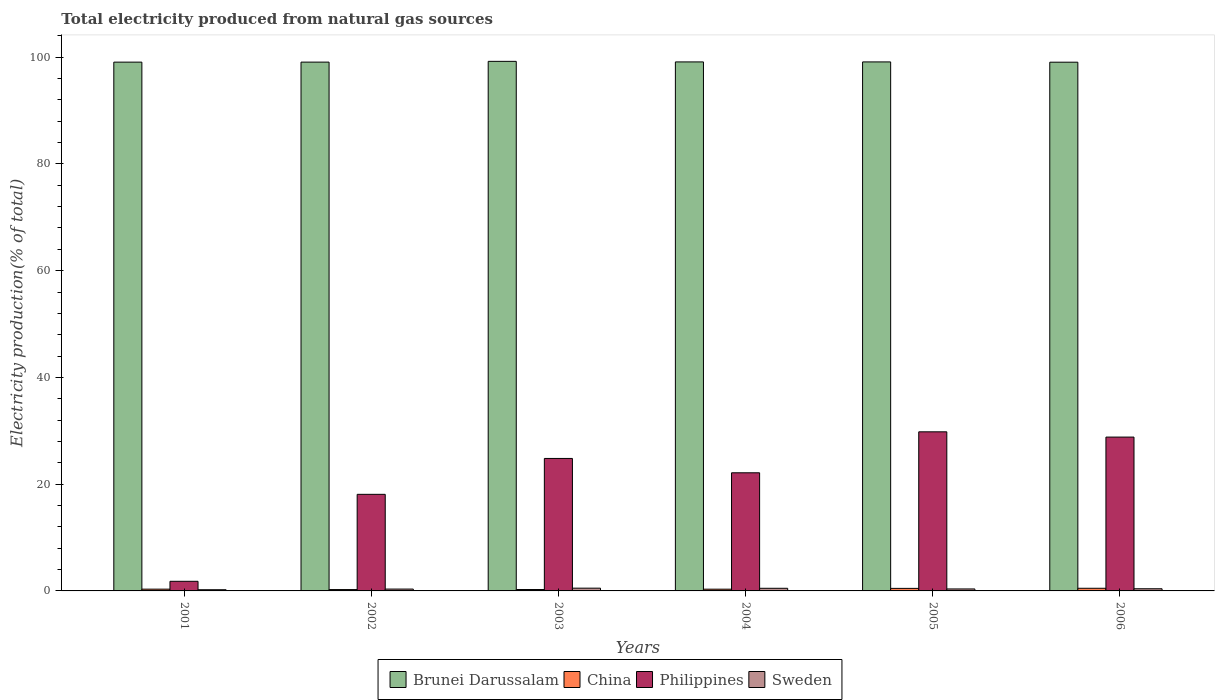How many bars are there on the 2nd tick from the left?
Your answer should be very brief. 4. In how many cases, is the number of bars for a given year not equal to the number of legend labels?
Give a very brief answer. 0. What is the total electricity produced in Philippines in 2006?
Your answer should be very brief. 28.82. Across all years, what is the maximum total electricity produced in Sweden?
Provide a short and direct response. 0.52. Across all years, what is the minimum total electricity produced in China?
Provide a succinct answer. 0.25. In which year was the total electricity produced in Sweden maximum?
Make the answer very short. 2003. What is the total total electricity produced in Philippines in the graph?
Your answer should be compact. 125.48. What is the difference between the total electricity produced in Brunei Darussalam in 2001 and that in 2006?
Offer a terse response. 0.01. What is the difference between the total electricity produced in Brunei Darussalam in 2005 and the total electricity produced in Philippines in 2001?
Keep it short and to the point. 97.31. What is the average total electricity produced in Brunei Darussalam per year?
Provide a short and direct response. 99.11. In the year 2006, what is the difference between the total electricity produced in Philippines and total electricity produced in China?
Your response must be concise. 28.33. What is the ratio of the total electricity produced in Brunei Darussalam in 2005 to that in 2006?
Your answer should be compact. 1. Is the total electricity produced in Brunei Darussalam in 2004 less than that in 2006?
Ensure brevity in your answer.  No. What is the difference between the highest and the second highest total electricity produced in Brunei Darussalam?
Offer a terse response. 0.11. What is the difference between the highest and the lowest total electricity produced in China?
Keep it short and to the point. 0.24. In how many years, is the total electricity produced in Brunei Darussalam greater than the average total electricity produced in Brunei Darussalam taken over all years?
Offer a very short reply. 3. Is the sum of the total electricity produced in Philippines in 2002 and 2006 greater than the maximum total electricity produced in Sweden across all years?
Provide a succinct answer. Yes. Is it the case that in every year, the sum of the total electricity produced in Brunei Darussalam and total electricity produced in Sweden is greater than the sum of total electricity produced in Philippines and total electricity produced in China?
Your answer should be very brief. Yes. What does the 3rd bar from the left in 2002 represents?
Make the answer very short. Philippines. What does the 1st bar from the right in 2006 represents?
Provide a short and direct response. Sweden. How many years are there in the graph?
Keep it short and to the point. 6. What is the difference between two consecutive major ticks on the Y-axis?
Provide a succinct answer. 20. Does the graph contain any zero values?
Keep it short and to the point. No. Does the graph contain grids?
Make the answer very short. No. How are the legend labels stacked?
Keep it short and to the point. Horizontal. What is the title of the graph?
Make the answer very short. Total electricity produced from natural gas sources. What is the label or title of the X-axis?
Offer a terse response. Years. What is the label or title of the Y-axis?
Provide a succinct answer. Electricity production(% of total). What is the Electricity production(% of total) of Brunei Darussalam in 2001?
Offer a terse response. 99.07. What is the Electricity production(% of total) of China in 2001?
Provide a short and direct response. 0.33. What is the Electricity production(% of total) of Philippines in 2001?
Keep it short and to the point. 1.8. What is the Electricity production(% of total) of Sweden in 2001?
Your response must be concise. 0.22. What is the Electricity production(% of total) of Brunei Darussalam in 2002?
Your response must be concise. 99.07. What is the Electricity production(% of total) in China in 2002?
Ensure brevity in your answer.  0.25. What is the Electricity production(% of total) of Philippines in 2002?
Make the answer very short. 18.1. What is the Electricity production(% of total) of Sweden in 2002?
Keep it short and to the point. 0.35. What is the Electricity production(% of total) of Brunei Darussalam in 2003?
Your answer should be compact. 99.22. What is the Electricity production(% of total) of China in 2003?
Keep it short and to the point. 0.26. What is the Electricity production(% of total) of Philippines in 2003?
Make the answer very short. 24.82. What is the Electricity production(% of total) of Sweden in 2003?
Provide a succinct answer. 0.52. What is the Electricity production(% of total) of Brunei Darussalam in 2004?
Keep it short and to the point. 99.11. What is the Electricity production(% of total) of China in 2004?
Your answer should be compact. 0.33. What is the Electricity production(% of total) in Philippines in 2004?
Provide a short and direct response. 22.13. What is the Electricity production(% of total) of Sweden in 2004?
Your answer should be compact. 0.49. What is the Electricity production(% of total) of Brunei Darussalam in 2005?
Provide a succinct answer. 99.11. What is the Electricity production(% of total) of China in 2005?
Provide a short and direct response. 0.48. What is the Electricity production(% of total) in Philippines in 2005?
Offer a terse response. 29.81. What is the Electricity production(% of total) of Sweden in 2005?
Your answer should be compact. 0.37. What is the Electricity production(% of total) in Brunei Darussalam in 2006?
Your response must be concise. 99.06. What is the Electricity production(% of total) in China in 2006?
Your answer should be compact. 0.5. What is the Electricity production(% of total) of Philippines in 2006?
Keep it short and to the point. 28.82. What is the Electricity production(% of total) of Sweden in 2006?
Your answer should be compact. 0.41. Across all years, what is the maximum Electricity production(% of total) in Brunei Darussalam?
Your answer should be very brief. 99.22. Across all years, what is the maximum Electricity production(% of total) in China?
Keep it short and to the point. 0.5. Across all years, what is the maximum Electricity production(% of total) in Philippines?
Provide a succinct answer. 29.81. Across all years, what is the maximum Electricity production(% of total) in Sweden?
Provide a short and direct response. 0.52. Across all years, what is the minimum Electricity production(% of total) of Brunei Darussalam?
Your answer should be compact. 99.06. Across all years, what is the minimum Electricity production(% of total) in China?
Provide a succinct answer. 0.25. Across all years, what is the minimum Electricity production(% of total) of Philippines?
Give a very brief answer. 1.8. Across all years, what is the minimum Electricity production(% of total) of Sweden?
Your answer should be compact. 0.22. What is the total Electricity production(% of total) of Brunei Darussalam in the graph?
Offer a terse response. 594.64. What is the total Electricity production(% of total) of China in the graph?
Make the answer very short. 2.15. What is the total Electricity production(% of total) of Philippines in the graph?
Provide a succinct answer. 125.48. What is the total Electricity production(% of total) of Sweden in the graph?
Offer a very short reply. 2.36. What is the difference between the Electricity production(% of total) of Brunei Darussalam in 2001 and that in 2002?
Offer a very short reply. -0.01. What is the difference between the Electricity production(% of total) in China in 2001 and that in 2002?
Offer a very short reply. 0.08. What is the difference between the Electricity production(% of total) of Philippines in 2001 and that in 2002?
Your answer should be compact. -16.29. What is the difference between the Electricity production(% of total) of Sweden in 2001 and that in 2002?
Your response must be concise. -0.12. What is the difference between the Electricity production(% of total) in Brunei Darussalam in 2001 and that in 2003?
Provide a succinct answer. -0.15. What is the difference between the Electricity production(% of total) of China in 2001 and that in 2003?
Provide a short and direct response. 0.07. What is the difference between the Electricity production(% of total) in Philippines in 2001 and that in 2003?
Offer a very short reply. -23.02. What is the difference between the Electricity production(% of total) of Sweden in 2001 and that in 2003?
Your answer should be compact. -0.29. What is the difference between the Electricity production(% of total) of Brunei Darussalam in 2001 and that in 2004?
Offer a terse response. -0.04. What is the difference between the Electricity production(% of total) in China in 2001 and that in 2004?
Offer a very short reply. 0.01. What is the difference between the Electricity production(% of total) in Philippines in 2001 and that in 2004?
Your answer should be compact. -20.33. What is the difference between the Electricity production(% of total) in Sweden in 2001 and that in 2004?
Make the answer very short. -0.27. What is the difference between the Electricity production(% of total) of Brunei Darussalam in 2001 and that in 2005?
Make the answer very short. -0.04. What is the difference between the Electricity production(% of total) in China in 2001 and that in 2005?
Your answer should be very brief. -0.14. What is the difference between the Electricity production(% of total) of Philippines in 2001 and that in 2005?
Keep it short and to the point. -28. What is the difference between the Electricity production(% of total) in Sweden in 2001 and that in 2005?
Your answer should be compact. -0.15. What is the difference between the Electricity production(% of total) of Brunei Darussalam in 2001 and that in 2006?
Provide a succinct answer. 0.01. What is the difference between the Electricity production(% of total) of China in 2001 and that in 2006?
Make the answer very short. -0.16. What is the difference between the Electricity production(% of total) in Philippines in 2001 and that in 2006?
Your response must be concise. -27.02. What is the difference between the Electricity production(% of total) in Sweden in 2001 and that in 2006?
Provide a succinct answer. -0.18. What is the difference between the Electricity production(% of total) in Brunei Darussalam in 2002 and that in 2003?
Give a very brief answer. -0.14. What is the difference between the Electricity production(% of total) in China in 2002 and that in 2003?
Give a very brief answer. -0.01. What is the difference between the Electricity production(% of total) of Philippines in 2002 and that in 2003?
Your answer should be compact. -6.72. What is the difference between the Electricity production(% of total) in Sweden in 2002 and that in 2003?
Your response must be concise. -0.17. What is the difference between the Electricity production(% of total) in Brunei Darussalam in 2002 and that in 2004?
Offer a very short reply. -0.04. What is the difference between the Electricity production(% of total) of China in 2002 and that in 2004?
Make the answer very short. -0.07. What is the difference between the Electricity production(% of total) of Philippines in 2002 and that in 2004?
Your answer should be very brief. -4.03. What is the difference between the Electricity production(% of total) of Sweden in 2002 and that in 2004?
Provide a succinct answer. -0.15. What is the difference between the Electricity production(% of total) in Brunei Darussalam in 2002 and that in 2005?
Your answer should be very brief. -0.04. What is the difference between the Electricity production(% of total) of China in 2002 and that in 2005?
Keep it short and to the point. -0.22. What is the difference between the Electricity production(% of total) of Philippines in 2002 and that in 2005?
Give a very brief answer. -11.71. What is the difference between the Electricity production(% of total) of Sweden in 2002 and that in 2005?
Ensure brevity in your answer.  -0.02. What is the difference between the Electricity production(% of total) in Brunei Darussalam in 2002 and that in 2006?
Your response must be concise. 0.01. What is the difference between the Electricity production(% of total) of China in 2002 and that in 2006?
Keep it short and to the point. -0.24. What is the difference between the Electricity production(% of total) of Philippines in 2002 and that in 2006?
Your answer should be compact. -10.73. What is the difference between the Electricity production(% of total) of Sweden in 2002 and that in 2006?
Your response must be concise. -0.06. What is the difference between the Electricity production(% of total) in Brunei Darussalam in 2003 and that in 2004?
Ensure brevity in your answer.  0.1. What is the difference between the Electricity production(% of total) of China in 2003 and that in 2004?
Your answer should be very brief. -0.06. What is the difference between the Electricity production(% of total) in Philippines in 2003 and that in 2004?
Offer a very short reply. 2.69. What is the difference between the Electricity production(% of total) of Sweden in 2003 and that in 2004?
Make the answer very short. 0.02. What is the difference between the Electricity production(% of total) of Brunei Darussalam in 2003 and that in 2005?
Offer a very short reply. 0.1. What is the difference between the Electricity production(% of total) of China in 2003 and that in 2005?
Make the answer very short. -0.21. What is the difference between the Electricity production(% of total) of Philippines in 2003 and that in 2005?
Offer a terse response. -4.99. What is the difference between the Electricity production(% of total) of Sweden in 2003 and that in 2005?
Provide a short and direct response. 0.15. What is the difference between the Electricity production(% of total) in Brunei Darussalam in 2003 and that in 2006?
Provide a succinct answer. 0.16. What is the difference between the Electricity production(% of total) of China in 2003 and that in 2006?
Keep it short and to the point. -0.23. What is the difference between the Electricity production(% of total) in Philippines in 2003 and that in 2006?
Provide a short and direct response. -4. What is the difference between the Electricity production(% of total) in Sweden in 2003 and that in 2006?
Provide a short and direct response. 0.11. What is the difference between the Electricity production(% of total) in China in 2004 and that in 2005?
Provide a short and direct response. -0.15. What is the difference between the Electricity production(% of total) of Philippines in 2004 and that in 2005?
Give a very brief answer. -7.68. What is the difference between the Electricity production(% of total) of Sweden in 2004 and that in 2005?
Ensure brevity in your answer.  0.12. What is the difference between the Electricity production(% of total) in Brunei Darussalam in 2004 and that in 2006?
Provide a short and direct response. 0.05. What is the difference between the Electricity production(% of total) of China in 2004 and that in 2006?
Ensure brevity in your answer.  -0.17. What is the difference between the Electricity production(% of total) of Philippines in 2004 and that in 2006?
Provide a succinct answer. -6.69. What is the difference between the Electricity production(% of total) in Sweden in 2004 and that in 2006?
Your answer should be compact. 0.09. What is the difference between the Electricity production(% of total) of Brunei Darussalam in 2005 and that in 2006?
Provide a succinct answer. 0.05. What is the difference between the Electricity production(% of total) in China in 2005 and that in 2006?
Make the answer very short. -0.02. What is the difference between the Electricity production(% of total) in Philippines in 2005 and that in 2006?
Your answer should be very brief. 0.99. What is the difference between the Electricity production(% of total) in Sweden in 2005 and that in 2006?
Your answer should be compact. -0.04. What is the difference between the Electricity production(% of total) in Brunei Darussalam in 2001 and the Electricity production(% of total) in China in 2002?
Offer a very short reply. 98.82. What is the difference between the Electricity production(% of total) in Brunei Darussalam in 2001 and the Electricity production(% of total) in Philippines in 2002?
Make the answer very short. 80.97. What is the difference between the Electricity production(% of total) of Brunei Darussalam in 2001 and the Electricity production(% of total) of Sweden in 2002?
Your answer should be very brief. 98.72. What is the difference between the Electricity production(% of total) of China in 2001 and the Electricity production(% of total) of Philippines in 2002?
Keep it short and to the point. -17.76. What is the difference between the Electricity production(% of total) of China in 2001 and the Electricity production(% of total) of Sweden in 2002?
Offer a terse response. -0.02. What is the difference between the Electricity production(% of total) in Philippines in 2001 and the Electricity production(% of total) in Sweden in 2002?
Offer a very short reply. 1.45. What is the difference between the Electricity production(% of total) in Brunei Darussalam in 2001 and the Electricity production(% of total) in China in 2003?
Your response must be concise. 98.81. What is the difference between the Electricity production(% of total) of Brunei Darussalam in 2001 and the Electricity production(% of total) of Philippines in 2003?
Your answer should be very brief. 74.25. What is the difference between the Electricity production(% of total) in Brunei Darussalam in 2001 and the Electricity production(% of total) in Sweden in 2003?
Keep it short and to the point. 98.55. What is the difference between the Electricity production(% of total) in China in 2001 and the Electricity production(% of total) in Philippines in 2003?
Ensure brevity in your answer.  -24.49. What is the difference between the Electricity production(% of total) in China in 2001 and the Electricity production(% of total) in Sweden in 2003?
Provide a succinct answer. -0.18. What is the difference between the Electricity production(% of total) of Philippines in 2001 and the Electricity production(% of total) of Sweden in 2003?
Your response must be concise. 1.29. What is the difference between the Electricity production(% of total) of Brunei Darussalam in 2001 and the Electricity production(% of total) of China in 2004?
Provide a short and direct response. 98.74. What is the difference between the Electricity production(% of total) of Brunei Darussalam in 2001 and the Electricity production(% of total) of Philippines in 2004?
Give a very brief answer. 76.94. What is the difference between the Electricity production(% of total) in Brunei Darussalam in 2001 and the Electricity production(% of total) in Sweden in 2004?
Offer a terse response. 98.58. What is the difference between the Electricity production(% of total) of China in 2001 and the Electricity production(% of total) of Philippines in 2004?
Ensure brevity in your answer.  -21.8. What is the difference between the Electricity production(% of total) in China in 2001 and the Electricity production(% of total) in Sweden in 2004?
Offer a terse response. -0.16. What is the difference between the Electricity production(% of total) in Philippines in 2001 and the Electricity production(% of total) in Sweden in 2004?
Your answer should be very brief. 1.31. What is the difference between the Electricity production(% of total) of Brunei Darussalam in 2001 and the Electricity production(% of total) of China in 2005?
Keep it short and to the point. 98.59. What is the difference between the Electricity production(% of total) in Brunei Darussalam in 2001 and the Electricity production(% of total) in Philippines in 2005?
Provide a succinct answer. 69.26. What is the difference between the Electricity production(% of total) in Brunei Darussalam in 2001 and the Electricity production(% of total) in Sweden in 2005?
Provide a short and direct response. 98.7. What is the difference between the Electricity production(% of total) of China in 2001 and the Electricity production(% of total) of Philippines in 2005?
Offer a terse response. -29.48. What is the difference between the Electricity production(% of total) in China in 2001 and the Electricity production(% of total) in Sweden in 2005?
Offer a very short reply. -0.04. What is the difference between the Electricity production(% of total) in Philippines in 2001 and the Electricity production(% of total) in Sweden in 2005?
Your response must be concise. 1.43. What is the difference between the Electricity production(% of total) of Brunei Darussalam in 2001 and the Electricity production(% of total) of China in 2006?
Give a very brief answer. 98.57. What is the difference between the Electricity production(% of total) of Brunei Darussalam in 2001 and the Electricity production(% of total) of Philippines in 2006?
Give a very brief answer. 70.25. What is the difference between the Electricity production(% of total) in Brunei Darussalam in 2001 and the Electricity production(% of total) in Sweden in 2006?
Provide a short and direct response. 98.66. What is the difference between the Electricity production(% of total) in China in 2001 and the Electricity production(% of total) in Philippines in 2006?
Your answer should be compact. -28.49. What is the difference between the Electricity production(% of total) in China in 2001 and the Electricity production(% of total) in Sweden in 2006?
Offer a very short reply. -0.07. What is the difference between the Electricity production(% of total) of Philippines in 2001 and the Electricity production(% of total) of Sweden in 2006?
Your answer should be compact. 1.4. What is the difference between the Electricity production(% of total) of Brunei Darussalam in 2002 and the Electricity production(% of total) of China in 2003?
Provide a succinct answer. 98.81. What is the difference between the Electricity production(% of total) of Brunei Darussalam in 2002 and the Electricity production(% of total) of Philippines in 2003?
Provide a succinct answer. 74.26. What is the difference between the Electricity production(% of total) of Brunei Darussalam in 2002 and the Electricity production(% of total) of Sweden in 2003?
Keep it short and to the point. 98.56. What is the difference between the Electricity production(% of total) of China in 2002 and the Electricity production(% of total) of Philippines in 2003?
Offer a terse response. -24.57. What is the difference between the Electricity production(% of total) in China in 2002 and the Electricity production(% of total) in Sweden in 2003?
Give a very brief answer. -0.26. What is the difference between the Electricity production(% of total) of Philippines in 2002 and the Electricity production(% of total) of Sweden in 2003?
Provide a short and direct response. 17.58. What is the difference between the Electricity production(% of total) of Brunei Darussalam in 2002 and the Electricity production(% of total) of China in 2004?
Your answer should be very brief. 98.75. What is the difference between the Electricity production(% of total) of Brunei Darussalam in 2002 and the Electricity production(% of total) of Philippines in 2004?
Provide a short and direct response. 76.94. What is the difference between the Electricity production(% of total) in Brunei Darussalam in 2002 and the Electricity production(% of total) in Sweden in 2004?
Give a very brief answer. 98.58. What is the difference between the Electricity production(% of total) in China in 2002 and the Electricity production(% of total) in Philippines in 2004?
Offer a terse response. -21.88. What is the difference between the Electricity production(% of total) of China in 2002 and the Electricity production(% of total) of Sweden in 2004?
Make the answer very short. -0.24. What is the difference between the Electricity production(% of total) in Philippines in 2002 and the Electricity production(% of total) in Sweden in 2004?
Make the answer very short. 17.6. What is the difference between the Electricity production(% of total) in Brunei Darussalam in 2002 and the Electricity production(% of total) in China in 2005?
Your answer should be compact. 98.6. What is the difference between the Electricity production(% of total) in Brunei Darussalam in 2002 and the Electricity production(% of total) in Philippines in 2005?
Provide a short and direct response. 69.27. What is the difference between the Electricity production(% of total) of Brunei Darussalam in 2002 and the Electricity production(% of total) of Sweden in 2005?
Make the answer very short. 98.7. What is the difference between the Electricity production(% of total) of China in 2002 and the Electricity production(% of total) of Philippines in 2005?
Provide a short and direct response. -29.55. What is the difference between the Electricity production(% of total) of China in 2002 and the Electricity production(% of total) of Sweden in 2005?
Offer a terse response. -0.12. What is the difference between the Electricity production(% of total) of Philippines in 2002 and the Electricity production(% of total) of Sweden in 2005?
Provide a short and direct response. 17.73. What is the difference between the Electricity production(% of total) in Brunei Darussalam in 2002 and the Electricity production(% of total) in China in 2006?
Your answer should be compact. 98.58. What is the difference between the Electricity production(% of total) in Brunei Darussalam in 2002 and the Electricity production(% of total) in Philippines in 2006?
Offer a very short reply. 70.25. What is the difference between the Electricity production(% of total) in Brunei Darussalam in 2002 and the Electricity production(% of total) in Sweden in 2006?
Provide a succinct answer. 98.67. What is the difference between the Electricity production(% of total) in China in 2002 and the Electricity production(% of total) in Philippines in 2006?
Your response must be concise. -28.57. What is the difference between the Electricity production(% of total) in China in 2002 and the Electricity production(% of total) in Sweden in 2006?
Provide a short and direct response. -0.15. What is the difference between the Electricity production(% of total) in Philippines in 2002 and the Electricity production(% of total) in Sweden in 2006?
Keep it short and to the point. 17.69. What is the difference between the Electricity production(% of total) of Brunei Darussalam in 2003 and the Electricity production(% of total) of China in 2004?
Keep it short and to the point. 98.89. What is the difference between the Electricity production(% of total) in Brunei Darussalam in 2003 and the Electricity production(% of total) in Philippines in 2004?
Keep it short and to the point. 77.09. What is the difference between the Electricity production(% of total) in Brunei Darussalam in 2003 and the Electricity production(% of total) in Sweden in 2004?
Ensure brevity in your answer.  98.72. What is the difference between the Electricity production(% of total) in China in 2003 and the Electricity production(% of total) in Philippines in 2004?
Keep it short and to the point. -21.87. What is the difference between the Electricity production(% of total) of China in 2003 and the Electricity production(% of total) of Sweden in 2004?
Your response must be concise. -0.23. What is the difference between the Electricity production(% of total) in Philippines in 2003 and the Electricity production(% of total) in Sweden in 2004?
Make the answer very short. 24.32. What is the difference between the Electricity production(% of total) in Brunei Darussalam in 2003 and the Electricity production(% of total) in China in 2005?
Offer a very short reply. 98.74. What is the difference between the Electricity production(% of total) of Brunei Darussalam in 2003 and the Electricity production(% of total) of Philippines in 2005?
Provide a short and direct response. 69.41. What is the difference between the Electricity production(% of total) in Brunei Darussalam in 2003 and the Electricity production(% of total) in Sweden in 2005?
Provide a short and direct response. 98.85. What is the difference between the Electricity production(% of total) of China in 2003 and the Electricity production(% of total) of Philippines in 2005?
Offer a terse response. -29.55. What is the difference between the Electricity production(% of total) of China in 2003 and the Electricity production(% of total) of Sweden in 2005?
Provide a succinct answer. -0.11. What is the difference between the Electricity production(% of total) in Philippines in 2003 and the Electricity production(% of total) in Sweden in 2005?
Give a very brief answer. 24.45. What is the difference between the Electricity production(% of total) of Brunei Darussalam in 2003 and the Electricity production(% of total) of China in 2006?
Your answer should be very brief. 98.72. What is the difference between the Electricity production(% of total) of Brunei Darussalam in 2003 and the Electricity production(% of total) of Philippines in 2006?
Make the answer very short. 70.39. What is the difference between the Electricity production(% of total) in Brunei Darussalam in 2003 and the Electricity production(% of total) in Sweden in 2006?
Provide a succinct answer. 98.81. What is the difference between the Electricity production(% of total) in China in 2003 and the Electricity production(% of total) in Philippines in 2006?
Make the answer very short. -28.56. What is the difference between the Electricity production(% of total) of China in 2003 and the Electricity production(% of total) of Sweden in 2006?
Ensure brevity in your answer.  -0.14. What is the difference between the Electricity production(% of total) in Philippines in 2003 and the Electricity production(% of total) in Sweden in 2006?
Offer a very short reply. 24.41. What is the difference between the Electricity production(% of total) in Brunei Darussalam in 2004 and the Electricity production(% of total) in China in 2005?
Make the answer very short. 98.63. What is the difference between the Electricity production(% of total) of Brunei Darussalam in 2004 and the Electricity production(% of total) of Philippines in 2005?
Your answer should be very brief. 69.3. What is the difference between the Electricity production(% of total) in Brunei Darussalam in 2004 and the Electricity production(% of total) in Sweden in 2005?
Your answer should be very brief. 98.74. What is the difference between the Electricity production(% of total) in China in 2004 and the Electricity production(% of total) in Philippines in 2005?
Ensure brevity in your answer.  -29.48. What is the difference between the Electricity production(% of total) in China in 2004 and the Electricity production(% of total) in Sweden in 2005?
Provide a succinct answer. -0.04. What is the difference between the Electricity production(% of total) of Philippines in 2004 and the Electricity production(% of total) of Sweden in 2005?
Your answer should be very brief. 21.76. What is the difference between the Electricity production(% of total) in Brunei Darussalam in 2004 and the Electricity production(% of total) in China in 2006?
Your answer should be very brief. 98.62. What is the difference between the Electricity production(% of total) of Brunei Darussalam in 2004 and the Electricity production(% of total) of Philippines in 2006?
Keep it short and to the point. 70.29. What is the difference between the Electricity production(% of total) in Brunei Darussalam in 2004 and the Electricity production(% of total) in Sweden in 2006?
Your answer should be compact. 98.71. What is the difference between the Electricity production(% of total) of China in 2004 and the Electricity production(% of total) of Philippines in 2006?
Your answer should be compact. -28.5. What is the difference between the Electricity production(% of total) of China in 2004 and the Electricity production(% of total) of Sweden in 2006?
Provide a succinct answer. -0.08. What is the difference between the Electricity production(% of total) in Philippines in 2004 and the Electricity production(% of total) in Sweden in 2006?
Give a very brief answer. 21.73. What is the difference between the Electricity production(% of total) in Brunei Darussalam in 2005 and the Electricity production(% of total) in China in 2006?
Ensure brevity in your answer.  98.62. What is the difference between the Electricity production(% of total) of Brunei Darussalam in 2005 and the Electricity production(% of total) of Philippines in 2006?
Give a very brief answer. 70.29. What is the difference between the Electricity production(% of total) of Brunei Darussalam in 2005 and the Electricity production(% of total) of Sweden in 2006?
Ensure brevity in your answer.  98.71. What is the difference between the Electricity production(% of total) in China in 2005 and the Electricity production(% of total) in Philippines in 2006?
Ensure brevity in your answer.  -28.35. What is the difference between the Electricity production(% of total) in China in 2005 and the Electricity production(% of total) in Sweden in 2006?
Your answer should be compact. 0.07. What is the difference between the Electricity production(% of total) of Philippines in 2005 and the Electricity production(% of total) of Sweden in 2006?
Your answer should be compact. 29.4. What is the average Electricity production(% of total) of Brunei Darussalam per year?
Offer a very short reply. 99.11. What is the average Electricity production(% of total) of China per year?
Give a very brief answer. 0.36. What is the average Electricity production(% of total) in Philippines per year?
Ensure brevity in your answer.  20.91. What is the average Electricity production(% of total) of Sweden per year?
Your answer should be compact. 0.39. In the year 2001, what is the difference between the Electricity production(% of total) of Brunei Darussalam and Electricity production(% of total) of China?
Make the answer very short. 98.74. In the year 2001, what is the difference between the Electricity production(% of total) of Brunei Darussalam and Electricity production(% of total) of Philippines?
Provide a succinct answer. 97.27. In the year 2001, what is the difference between the Electricity production(% of total) of Brunei Darussalam and Electricity production(% of total) of Sweden?
Provide a succinct answer. 98.85. In the year 2001, what is the difference between the Electricity production(% of total) in China and Electricity production(% of total) in Philippines?
Offer a very short reply. -1.47. In the year 2001, what is the difference between the Electricity production(% of total) of China and Electricity production(% of total) of Sweden?
Ensure brevity in your answer.  0.11. In the year 2001, what is the difference between the Electricity production(% of total) in Philippines and Electricity production(% of total) in Sweden?
Your answer should be very brief. 1.58. In the year 2002, what is the difference between the Electricity production(% of total) of Brunei Darussalam and Electricity production(% of total) of China?
Keep it short and to the point. 98.82. In the year 2002, what is the difference between the Electricity production(% of total) of Brunei Darussalam and Electricity production(% of total) of Philippines?
Provide a succinct answer. 80.98. In the year 2002, what is the difference between the Electricity production(% of total) of Brunei Darussalam and Electricity production(% of total) of Sweden?
Your answer should be very brief. 98.73. In the year 2002, what is the difference between the Electricity production(% of total) of China and Electricity production(% of total) of Philippines?
Provide a succinct answer. -17.84. In the year 2002, what is the difference between the Electricity production(% of total) of China and Electricity production(% of total) of Sweden?
Your response must be concise. -0.09. In the year 2002, what is the difference between the Electricity production(% of total) in Philippines and Electricity production(% of total) in Sweden?
Give a very brief answer. 17.75. In the year 2003, what is the difference between the Electricity production(% of total) of Brunei Darussalam and Electricity production(% of total) of China?
Keep it short and to the point. 98.95. In the year 2003, what is the difference between the Electricity production(% of total) of Brunei Darussalam and Electricity production(% of total) of Philippines?
Ensure brevity in your answer.  74.4. In the year 2003, what is the difference between the Electricity production(% of total) of Brunei Darussalam and Electricity production(% of total) of Sweden?
Your answer should be compact. 98.7. In the year 2003, what is the difference between the Electricity production(% of total) of China and Electricity production(% of total) of Philippines?
Offer a terse response. -24.56. In the year 2003, what is the difference between the Electricity production(% of total) in China and Electricity production(% of total) in Sweden?
Keep it short and to the point. -0.25. In the year 2003, what is the difference between the Electricity production(% of total) of Philippines and Electricity production(% of total) of Sweden?
Keep it short and to the point. 24.3. In the year 2004, what is the difference between the Electricity production(% of total) in Brunei Darussalam and Electricity production(% of total) in China?
Your answer should be very brief. 98.78. In the year 2004, what is the difference between the Electricity production(% of total) of Brunei Darussalam and Electricity production(% of total) of Philippines?
Keep it short and to the point. 76.98. In the year 2004, what is the difference between the Electricity production(% of total) in Brunei Darussalam and Electricity production(% of total) in Sweden?
Offer a terse response. 98.62. In the year 2004, what is the difference between the Electricity production(% of total) of China and Electricity production(% of total) of Philippines?
Your response must be concise. -21.8. In the year 2004, what is the difference between the Electricity production(% of total) in China and Electricity production(% of total) in Sweden?
Provide a succinct answer. -0.17. In the year 2004, what is the difference between the Electricity production(% of total) of Philippines and Electricity production(% of total) of Sweden?
Your answer should be very brief. 21.64. In the year 2005, what is the difference between the Electricity production(% of total) in Brunei Darussalam and Electricity production(% of total) in China?
Make the answer very short. 98.63. In the year 2005, what is the difference between the Electricity production(% of total) of Brunei Darussalam and Electricity production(% of total) of Philippines?
Make the answer very short. 69.3. In the year 2005, what is the difference between the Electricity production(% of total) of Brunei Darussalam and Electricity production(% of total) of Sweden?
Offer a very short reply. 98.74. In the year 2005, what is the difference between the Electricity production(% of total) of China and Electricity production(% of total) of Philippines?
Make the answer very short. -29.33. In the year 2005, what is the difference between the Electricity production(% of total) in China and Electricity production(% of total) in Sweden?
Give a very brief answer. 0.11. In the year 2005, what is the difference between the Electricity production(% of total) in Philippines and Electricity production(% of total) in Sweden?
Give a very brief answer. 29.44. In the year 2006, what is the difference between the Electricity production(% of total) of Brunei Darussalam and Electricity production(% of total) of China?
Ensure brevity in your answer.  98.56. In the year 2006, what is the difference between the Electricity production(% of total) of Brunei Darussalam and Electricity production(% of total) of Philippines?
Ensure brevity in your answer.  70.24. In the year 2006, what is the difference between the Electricity production(% of total) of Brunei Darussalam and Electricity production(% of total) of Sweden?
Your answer should be compact. 98.65. In the year 2006, what is the difference between the Electricity production(% of total) in China and Electricity production(% of total) in Philippines?
Provide a short and direct response. -28.33. In the year 2006, what is the difference between the Electricity production(% of total) in China and Electricity production(% of total) in Sweden?
Provide a short and direct response. 0.09. In the year 2006, what is the difference between the Electricity production(% of total) of Philippines and Electricity production(% of total) of Sweden?
Give a very brief answer. 28.42. What is the ratio of the Electricity production(% of total) in Brunei Darussalam in 2001 to that in 2002?
Provide a succinct answer. 1. What is the ratio of the Electricity production(% of total) of China in 2001 to that in 2002?
Your answer should be very brief. 1.31. What is the ratio of the Electricity production(% of total) in Philippines in 2001 to that in 2002?
Make the answer very short. 0.1. What is the ratio of the Electricity production(% of total) in Sweden in 2001 to that in 2002?
Keep it short and to the point. 0.64. What is the ratio of the Electricity production(% of total) of China in 2001 to that in 2003?
Offer a terse response. 1.27. What is the ratio of the Electricity production(% of total) of Philippines in 2001 to that in 2003?
Your response must be concise. 0.07. What is the ratio of the Electricity production(% of total) of Sweden in 2001 to that in 2003?
Your answer should be compact. 0.43. What is the ratio of the Electricity production(% of total) in China in 2001 to that in 2004?
Ensure brevity in your answer.  1.02. What is the ratio of the Electricity production(% of total) of Philippines in 2001 to that in 2004?
Give a very brief answer. 0.08. What is the ratio of the Electricity production(% of total) of Sweden in 2001 to that in 2004?
Give a very brief answer. 0.45. What is the ratio of the Electricity production(% of total) of Brunei Darussalam in 2001 to that in 2005?
Your response must be concise. 1. What is the ratio of the Electricity production(% of total) of China in 2001 to that in 2005?
Your answer should be compact. 0.7. What is the ratio of the Electricity production(% of total) of Philippines in 2001 to that in 2005?
Offer a very short reply. 0.06. What is the ratio of the Electricity production(% of total) in Sweden in 2001 to that in 2005?
Offer a very short reply. 0.6. What is the ratio of the Electricity production(% of total) in Brunei Darussalam in 2001 to that in 2006?
Provide a short and direct response. 1. What is the ratio of the Electricity production(% of total) in China in 2001 to that in 2006?
Provide a succinct answer. 0.67. What is the ratio of the Electricity production(% of total) in Philippines in 2001 to that in 2006?
Provide a succinct answer. 0.06. What is the ratio of the Electricity production(% of total) in Sweden in 2001 to that in 2006?
Make the answer very short. 0.55. What is the ratio of the Electricity production(% of total) in Brunei Darussalam in 2002 to that in 2003?
Your answer should be compact. 1. What is the ratio of the Electricity production(% of total) of China in 2002 to that in 2003?
Your answer should be compact. 0.96. What is the ratio of the Electricity production(% of total) in Philippines in 2002 to that in 2003?
Give a very brief answer. 0.73. What is the ratio of the Electricity production(% of total) of Sweden in 2002 to that in 2003?
Your answer should be compact. 0.67. What is the ratio of the Electricity production(% of total) of China in 2002 to that in 2004?
Offer a terse response. 0.77. What is the ratio of the Electricity production(% of total) of Philippines in 2002 to that in 2004?
Give a very brief answer. 0.82. What is the ratio of the Electricity production(% of total) in Sweden in 2002 to that in 2004?
Your response must be concise. 0.7. What is the ratio of the Electricity production(% of total) in China in 2002 to that in 2005?
Your answer should be compact. 0.53. What is the ratio of the Electricity production(% of total) of Philippines in 2002 to that in 2005?
Keep it short and to the point. 0.61. What is the ratio of the Electricity production(% of total) of Sweden in 2002 to that in 2005?
Your response must be concise. 0.94. What is the ratio of the Electricity production(% of total) of China in 2002 to that in 2006?
Your answer should be compact. 0.51. What is the ratio of the Electricity production(% of total) of Philippines in 2002 to that in 2006?
Offer a very short reply. 0.63. What is the ratio of the Electricity production(% of total) in Sweden in 2002 to that in 2006?
Your response must be concise. 0.86. What is the ratio of the Electricity production(% of total) in Brunei Darussalam in 2003 to that in 2004?
Your answer should be compact. 1. What is the ratio of the Electricity production(% of total) of China in 2003 to that in 2004?
Keep it short and to the point. 0.8. What is the ratio of the Electricity production(% of total) of Philippines in 2003 to that in 2004?
Keep it short and to the point. 1.12. What is the ratio of the Electricity production(% of total) in Sweden in 2003 to that in 2004?
Your response must be concise. 1.05. What is the ratio of the Electricity production(% of total) of Brunei Darussalam in 2003 to that in 2005?
Keep it short and to the point. 1. What is the ratio of the Electricity production(% of total) of China in 2003 to that in 2005?
Your answer should be compact. 0.55. What is the ratio of the Electricity production(% of total) of Philippines in 2003 to that in 2005?
Provide a succinct answer. 0.83. What is the ratio of the Electricity production(% of total) in Sweden in 2003 to that in 2005?
Your response must be concise. 1.4. What is the ratio of the Electricity production(% of total) in China in 2003 to that in 2006?
Offer a very short reply. 0.53. What is the ratio of the Electricity production(% of total) in Philippines in 2003 to that in 2006?
Ensure brevity in your answer.  0.86. What is the ratio of the Electricity production(% of total) of Sweden in 2003 to that in 2006?
Keep it short and to the point. 1.27. What is the ratio of the Electricity production(% of total) in Brunei Darussalam in 2004 to that in 2005?
Your response must be concise. 1. What is the ratio of the Electricity production(% of total) of China in 2004 to that in 2005?
Provide a succinct answer. 0.69. What is the ratio of the Electricity production(% of total) in Philippines in 2004 to that in 2005?
Your answer should be very brief. 0.74. What is the ratio of the Electricity production(% of total) in Sweden in 2004 to that in 2005?
Provide a short and direct response. 1.34. What is the ratio of the Electricity production(% of total) of China in 2004 to that in 2006?
Offer a very short reply. 0.66. What is the ratio of the Electricity production(% of total) of Philippines in 2004 to that in 2006?
Provide a short and direct response. 0.77. What is the ratio of the Electricity production(% of total) of Sweden in 2004 to that in 2006?
Give a very brief answer. 1.22. What is the ratio of the Electricity production(% of total) in China in 2005 to that in 2006?
Keep it short and to the point. 0.96. What is the ratio of the Electricity production(% of total) in Philippines in 2005 to that in 2006?
Your response must be concise. 1.03. What is the ratio of the Electricity production(% of total) of Sweden in 2005 to that in 2006?
Make the answer very short. 0.91. What is the difference between the highest and the second highest Electricity production(% of total) in Brunei Darussalam?
Give a very brief answer. 0.1. What is the difference between the highest and the second highest Electricity production(% of total) in China?
Your response must be concise. 0.02. What is the difference between the highest and the second highest Electricity production(% of total) of Philippines?
Provide a succinct answer. 0.99. What is the difference between the highest and the second highest Electricity production(% of total) of Sweden?
Keep it short and to the point. 0.02. What is the difference between the highest and the lowest Electricity production(% of total) of Brunei Darussalam?
Provide a succinct answer. 0.16. What is the difference between the highest and the lowest Electricity production(% of total) of China?
Ensure brevity in your answer.  0.24. What is the difference between the highest and the lowest Electricity production(% of total) in Philippines?
Your answer should be very brief. 28. What is the difference between the highest and the lowest Electricity production(% of total) of Sweden?
Provide a succinct answer. 0.29. 